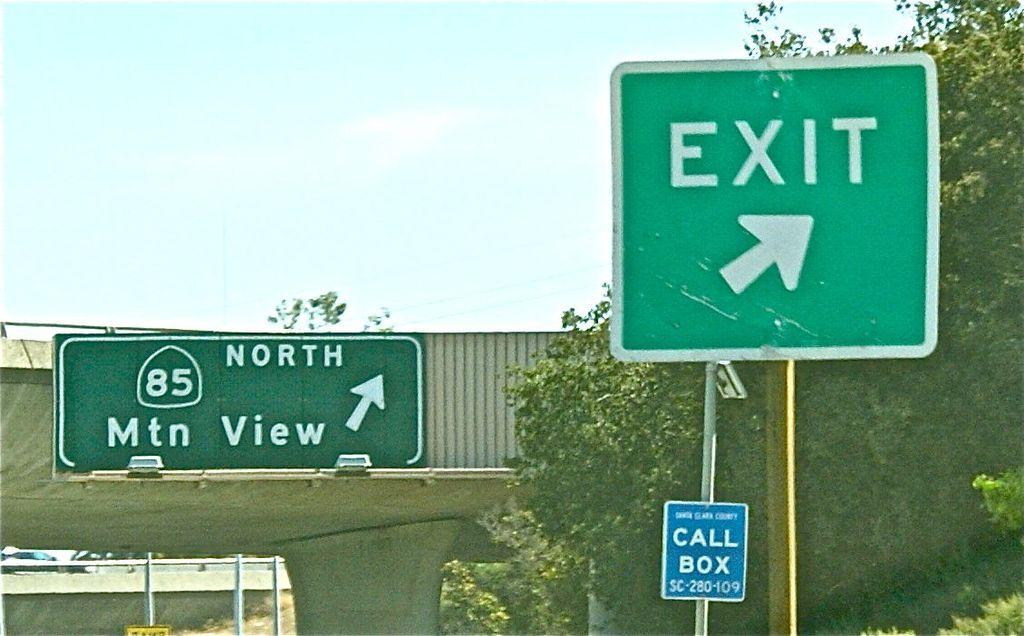<image>
Relay a brief, clear account of the picture shown. An exit sign just before the North 85 ramp 